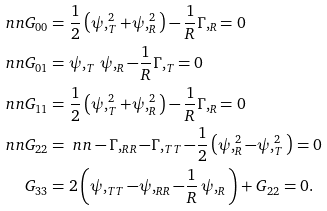<formula> <loc_0><loc_0><loc_500><loc_500>\ n n G _ { 0 0 } & = \frac { 1 } { 2 } \left ( \psi , ^ { 2 } _ { T } + \psi , ^ { 2 } _ { R } \right ) - \frac { 1 } { R } \Gamma , _ { R } = 0 \\ \ n n G _ { 0 1 } & = \psi , _ { T } \, \psi , _ { R } - \frac { 1 } { R } \Gamma , _ { T } = 0 \\ \ n n G _ { 1 1 } & = \frac { 1 } { 2 } \left ( \psi , ^ { 2 } _ { T } + \psi , ^ { 2 } _ { R } \right ) - \frac { 1 } { R } \Gamma , _ { R } = 0 \\ \ n n G _ { 2 2 } & = \ n n - \Gamma , _ { R R } - \Gamma , _ { T T } - \frac { 1 } { 2 } \left ( \psi , ^ { 2 } _ { R } - \psi , ^ { 2 } _ { T } \right ) = 0 \\ G _ { 3 3 } & = 2 \left ( \psi , _ { T T } - \psi , _ { R R } - \frac { 1 } { R } \, \psi , _ { R } \right ) + G _ { 2 2 } = 0 .</formula> 